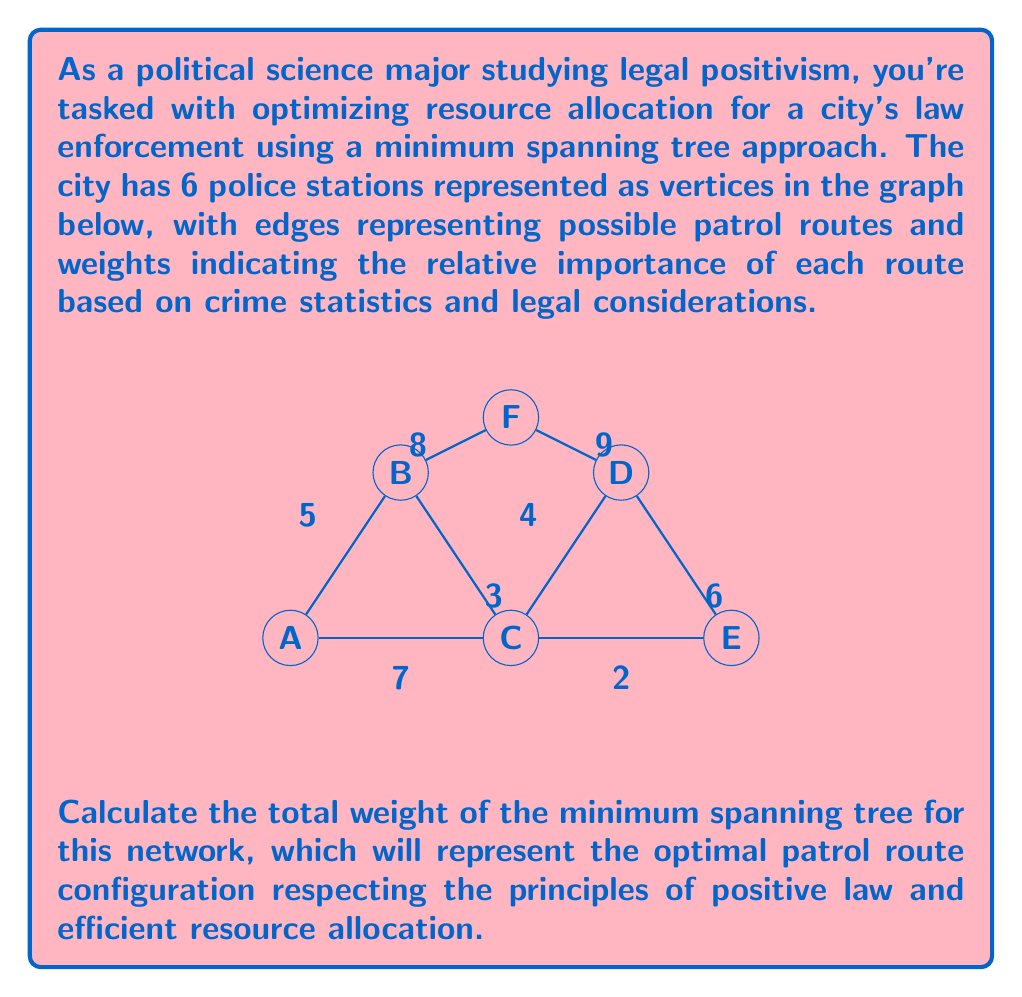Solve this math problem. To solve this problem, we'll use Kruskal's algorithm to find the minimum spanning tree (MST) of the given graph. This approach aligns with the principles of legal positivism by adhering to a structured, rule-based method for decision-making.

Step 1: Sort the edges by weight in ascending order:
1. C-E (2)
2. B-C (3)
3. C-D (4)
4. A-B (5)
5. D-E (6)
6. A-C (7)
7. B-F (8)
8. D-F (9)

Step 2: Apply Kruskal's algorithm:
1. Add C-E (2) to the MST
2. Add B-C (3) to the MST
3. Add C-D (4) to the MST
4. Add A-B (5) to the MST

At this point, we have connected all vertices with 5 edges (n-1 edges for n vertices), so we stop.

Step 3: Calculate the total weight of the MST:
$$\text{Total Weight} = 2 + 3 + 4 + 5 = 14$$

This result represents the optimal patrol route configuration that balances the importance of each route based on crime statistics and legal considerations, while ensuring all stations are connected with the minimum total weight.
Answer: 14 